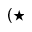<formula> <loc_0><loc_0><loc_500><loc_500>( { ^ { * } }</formula> 